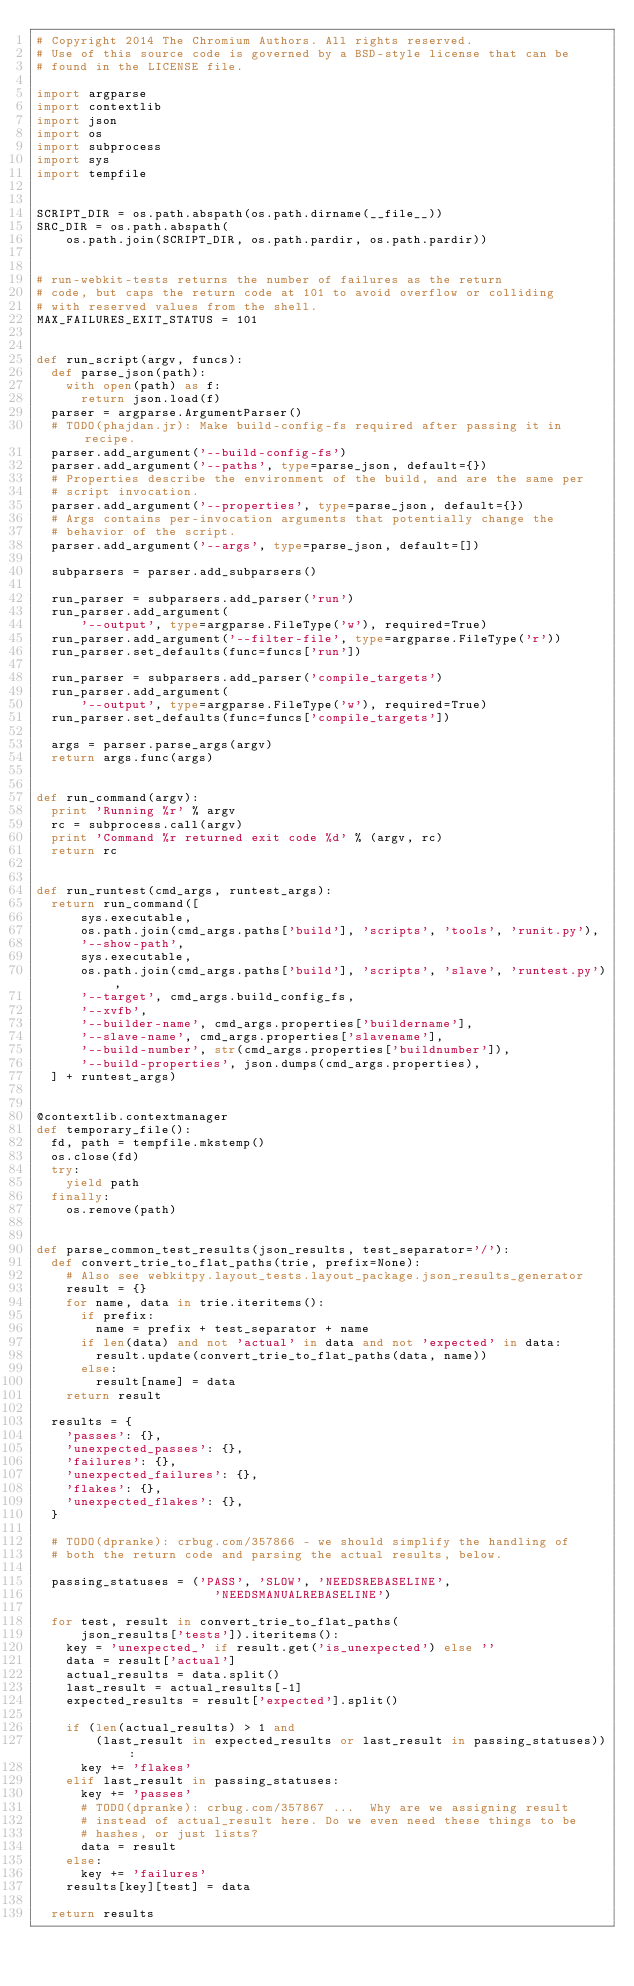<code> <loc_0><loc_0><loc_500><loc_500><_Python_># Copyright 2014 The Chromium Authors. All rights reserved.
# Use of this source code is governed by a BSD-style license that can be
# found in the LICENSE file.

import argparse
import contextlib
import json
import os
import subprocess
import sys
import tempfile


SCRIPT_DIR = os.path.abspath(os.path.dirname(__file__))
SRC_DIR = os.path.abspath(
    os.path.join(SCRIPT_DIR, os.path.pardir, os.path.pardir))


# run-webkit-tests returns the number of failures as the return
# code, but caps the return code at 101 to avoid overflow or colliding
# with reserved values from the shell.
MAX_FAILURES_EXIT_STATUS = 101


def run_script(argv, funcs):
  def parse_json(path):
    with open(path) as f:
      return json.load(f)
  parser = argparse.ArgumentParser()
  # TODO(phajdan.jr): Make build-config-fs required after passing it in recipe.
  parser.add_argument('--build-config-fs')
  parser.add_argument('--paths', type=parse_json, default={})
  # Properties describe the environment of the build, and are the same per
  # script invocation.
  parser.add_argument('--properties', type=parse_json, default={})
  # Args contains per-invocation arguments that potentially change the
  # behavior of the script.
  parser.add_argument('--args', type=parse_json, default=[])

  subparsers = parser.add_subparsers()

  run_parser = subparsers.add_parser('run')
  run_parser.add_argument(
      '--output', type=argparse.FileType('w'), required=True)
  run_parser.add_argument('--filter-file', type=argparse.FileType('r'))
  run_parser.set_defaults(func=funcs['run'])

  run_parser = subparsers.add_parser('compile_targets')
  run_parser.add_argument(
      '--output', type=argparse.FileType('w'), required=True)
  run_parser.set_defaults(func=funcs['compile_targets'])

  args = parser.parse_args(argv)
  return args.func(args)


def run_command(argv):
  print 'Running %r' % argv
  rc = subprocess.call(argv)
  print 'Command %r returned exit code %d' % (argv, rc)
  return rc


def run_runtest(cmd_args, runtest_args):
  return run_command([
      sys.executable,
      os.path.join(cmd_args.paths['build'], 'scripts', 'tools', 'runit.py'),
      '--show-path',
      sys.executable,
      os.path.join(cmd_args.paths['build'], 'scripts', 'slave', 'runtest.py'),
      '--target', cmd_args.build_config_fs,
      '--xvfb',
      '--builder-name', cmd_args.properties['buildername'],
      '--slave-name', cmd_args.properties['slavename'],
      '--build-number', str(cmd_args.properties['buildnumber']),
      '--build-properties', json.dumps(cmd_args.properties),
  ] + runtest_args)


@contextlib.contextmanager
def temporary_file():
  fd, path = tempfile.mkstemp()
  os.close(fd)
  try:
    yield path
  finally:
    os.remove(path)


def parse_common_test_results(json_results, test_separator='/'):
  def convert_trie_to_flat_paths(trie, prefix=None):
    # Also see webkitpy.layout_tests.layout_package.json_results_generator
    result = {}
    for name, data in trie.iteritems():
      if prefix:
        name = prefix + test_separator + name
      if len(data) and not 'actual' in data and not 'expected' in data:
        result.update(convert_trie_to_flat_paths(data, name))
      else:
        result[name] = data
    return result

  results = {
    'passes': {},
    'unexpected_passes': {},
    'failures': {},
    'unexpected_failures': {},
    'flakes': {},
    'unexpected_flakes': {},
  }

  # TODO(dpranke): crbug.com/357866 - we should simplify the handling of
  # both the return code and parsing the actual results, below.

  passing_statuses = ('PASS', 'SLOW', 'NEEDSREBASELINE',
                        'NEEDSMANUALREBASELINE')

  for test, result in convert_trie_to_flat_paths(
      json_results['tests']).iteritems():
    key = 'unexpected_' if result.get('is_unexpected') else ''
    data = result['actual']
    actual_results = data.split()
    last_result = actual_results[-1]
    expected_results = result['expected'].split()

    if (len(actual_results) > 1 and
        (last_result in expected_results or last_result in passing_statuses)):
      key += 'flakes'
    elif last_result in passing_statuses:
      key += 'passes'
      # TODO(dpranke): crbug.com/357867 ...  Why are we assigning result
      # instead of actual_result here. Do we even need these things to be
      # hashes, or just lists?
      data = result
    else:
      key += 'failures'
    results[key][test] = data

  return results
</code> 